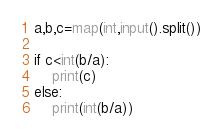<code> <loc_0><loc_0><loc_500><loc_500><_Python_>a,b,c=map(int,input().split())

if c<int(b/a):
    print(c)
else:
    print(int(b/a))</code> 